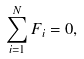Convert formula to latex. <formula><loc_0><loc_0><loc_500><loc_500>\sum ^ { N } _ { i = 1 } F _ { i } = 0 ,</formula> 